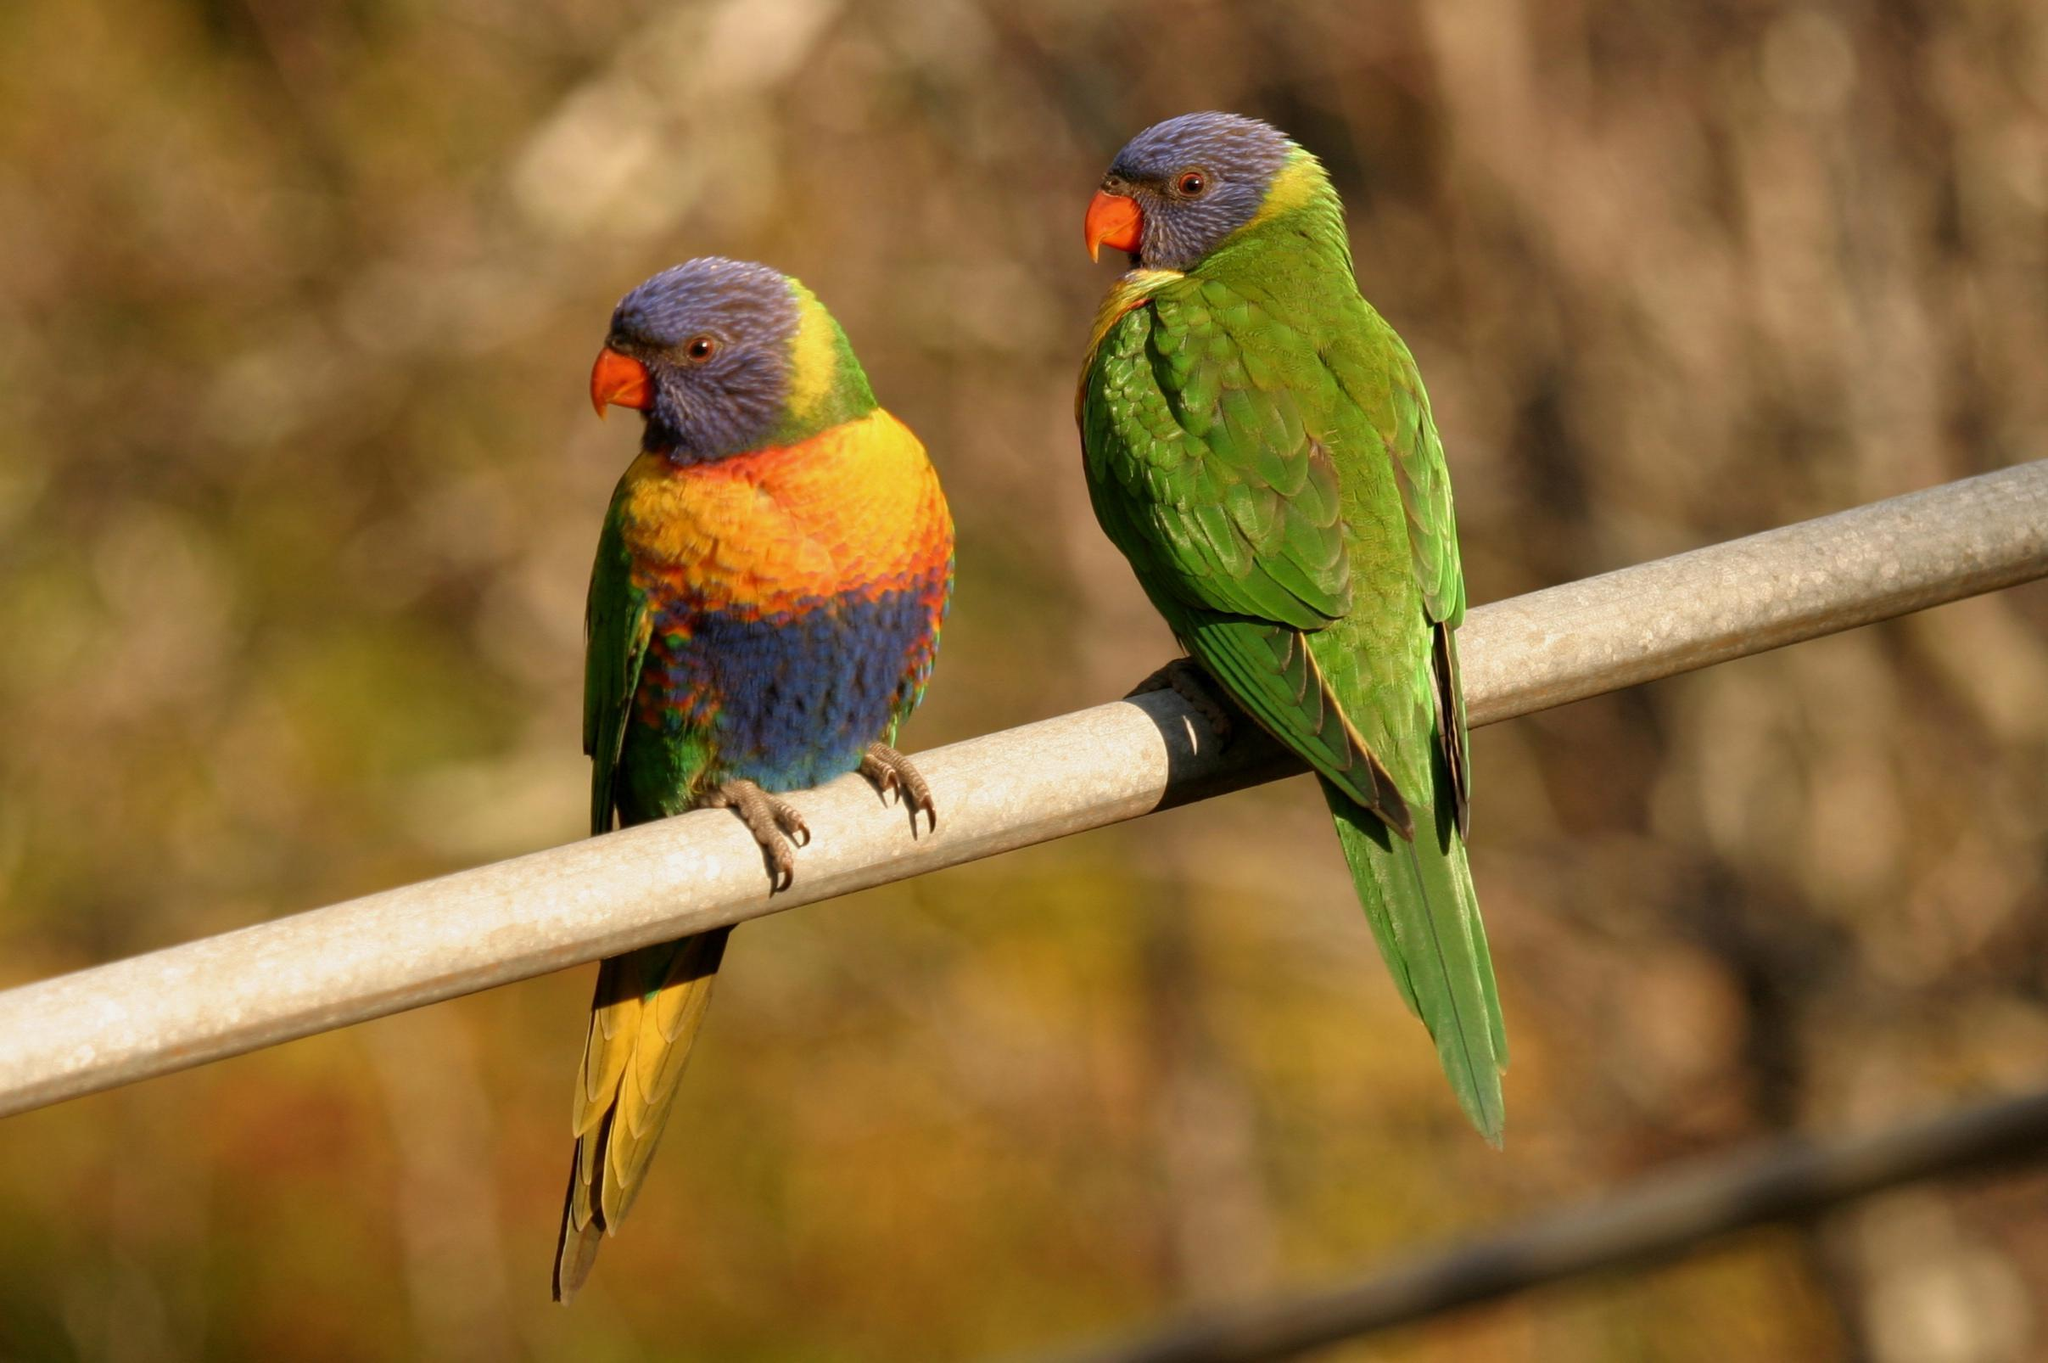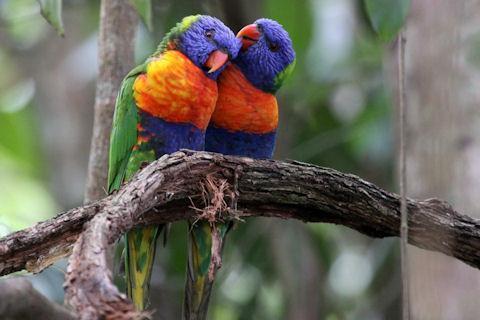The first image is the image on the left, the second image is the image on the right. Considering the images on both sides, is "the right image has two birds next to each other on a branch" valid? Answer yes or no. Yes. The first image is the image on the left, the second image is the image on the right. Assess this claim about the two images: "There are two birds in each image.". Correct or not? Answer yes or no. Yes. 